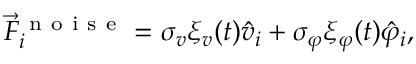<formula> <loc_0><loc_0><loc_500><loc_500>\vec { F } _ { i } ^ { n o i s e } = \sigma _ { v } \xi _ { v } ( t ) \hat { v } _ { i } + \sigma _ { \varphi } \xi _ { \varphi } ( t ) \hat { \varphi } _ { i } ,</formula> 